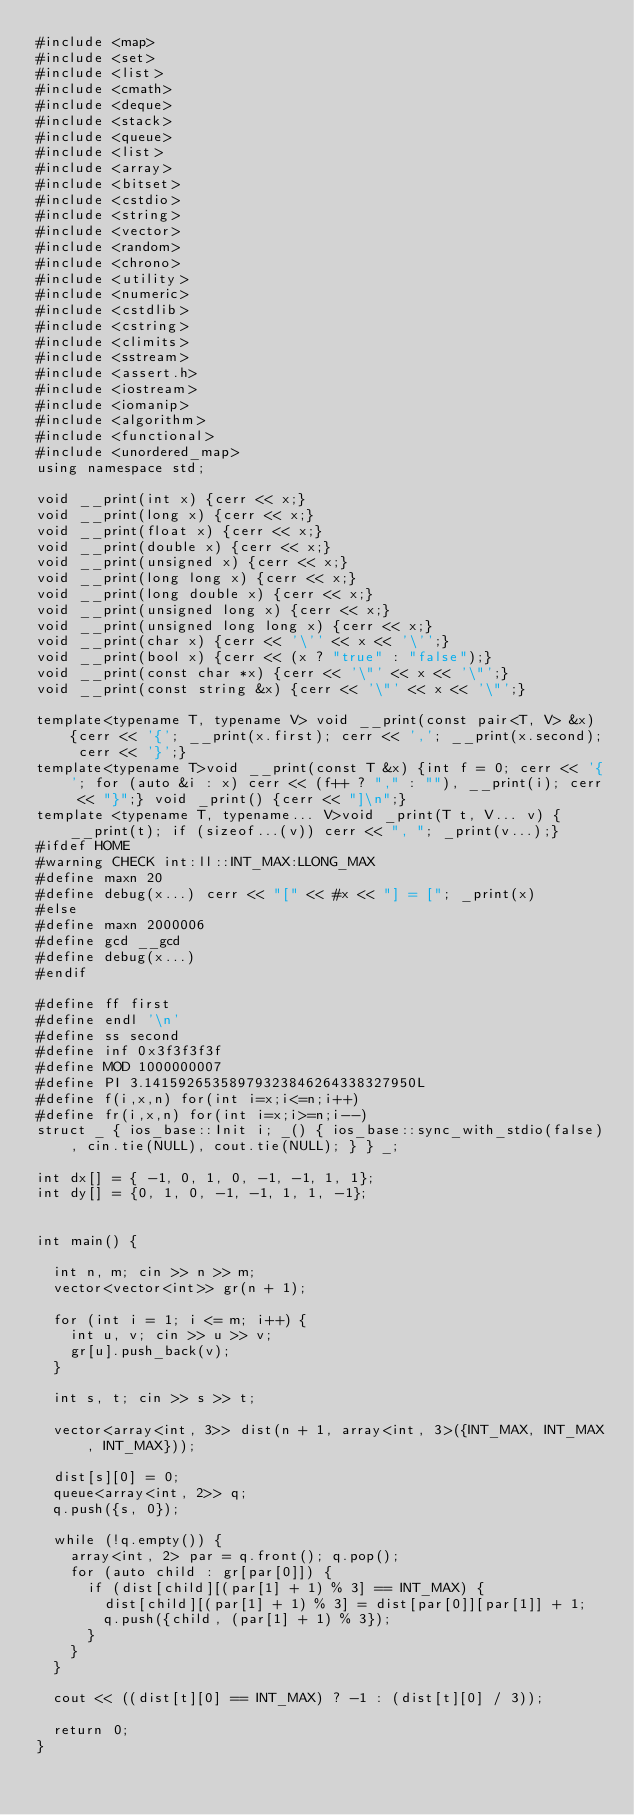<code> <loc_0><loc_0><loc_500><loc_500><_C++_>#include <map>
#include <set>
#include <list>
#include <cmath>
#include <deque>
#include <stack>
#include <queue>
#include <list>
#include <array>
#include <bitset>
#include <cstdio>
#include <string>
#include <vector>
#include <random>
#include <chrono>
#include <utility>
#include <numeric>
#include <cstdlib>
#include <cstring>
#include <climits>
#include <sstream>
#include <assert.h>
#include <iostream>
#include <iomanip>
#include <algorithm>
#include <functional>
#include <unordered_map>
using namespace std;

void __print(int x) {cerr << x;}
void __print(long x) {cerr << x;}
void __print(float x) {cerr << x;}
void __print(double x) {cerr << x;}
void __print(unsigned x) {cerr << x;}
void __print(long long x) {cerr << x;}
void __print(long double x) {cerr << x;}
void __print(unsigned long x) {cerr << x;}
void __print(unsigned long long x) {cerr << x;}
void __print(char x) {cerr << '\'' << x << '\'';}
void __print(bool x) {cerr << (x ? "true" : "false");}
void __print(const char *x) {cerr << '\"' << x << '\"';}
void __print(const string &x) {cerr << '\"' << x << '\"';}

template<typename T, typename V> void __print(const pair<T, V> &x) {cerr << '{'; __print(x.first); cerr << ','; __print(x.second); cerr << '}';}
template<typename T>void __print(const T &x) {int f = 0; cerr << '{'; for (auto &i : x) cerr << (f++ ? "," : ""), __print(i); cerr << "}";} void _print() {cerr << "]\n";}
template <typename T, typename... V>void _print(T t, V... v) {__print(t); if (sizeof...(v)) cerr << ", "; _print(v...);}
#ifdef HOME
#warning CHECK int:ll::INT_MAX:LLONG_MAX
#define maxn 20
#define debug(x...) cerr << "[" << #x << "] = ["; _print(x)
#else
#define maxn 2000006
#define gcd __gcd
#define debug(x...)
#endif

#define ff first
#define endl '\n'
#define ss second
#define inf 0x3f3f3f3f
#define MOD 1000000007
#define PI 3.14159265358979323846264338327950L
#define f(i,x,n) for(int i=x;i<=n;i++)
#define fr(i,x,n) for(int i=x;i>=n;i--)
struct _ { ios_base::Init i; _() { ios_base::sync_with_stdio(false), cin.tie(NULL), cout.tie(NULL); } } _;

int dx[] = { -1, 0, 1, 0, -1, -1, 1, 1};
int dy[] = {0, 1, 0, -1, -1, 1, 1, -1};


int main() {

	int n, m; cin >> n >> m;
	vector<vector<int>> gr(n + 1);

	for (int i = 1; i <= m; i++) {
		int u, v; cin >> u >> v;
		gr[u].push_back(v);
	}

	int s, t; cin >> s >> t;

	vector<array<int, 3>> dist(n + 1, array<int, 3>({INT_MAX, INT_MAX, INT_MAX}));

	dist[s][0] = 0;
	queue<array<int, 2>> q;
	q.push({s, 0});

	while (!q.empty()) {
		array<int, 2> par = q.front(); q.pop();
		for (auto child : gr[par[0]]) {
			if (dist[child][(par[1] + 1) % 3] == INT_MAX) {
				dist[child][(par[1] + 1) % 3] = dist[par[0]][par[1]] + 1;
				q.push({child, (par[1] + 1) % 3});
			}
		}
	}

	cout << ((dist[t][0] == INT_MAX) ? -1 : (dist[t][0] / 3));

	return 0;
}</code> 